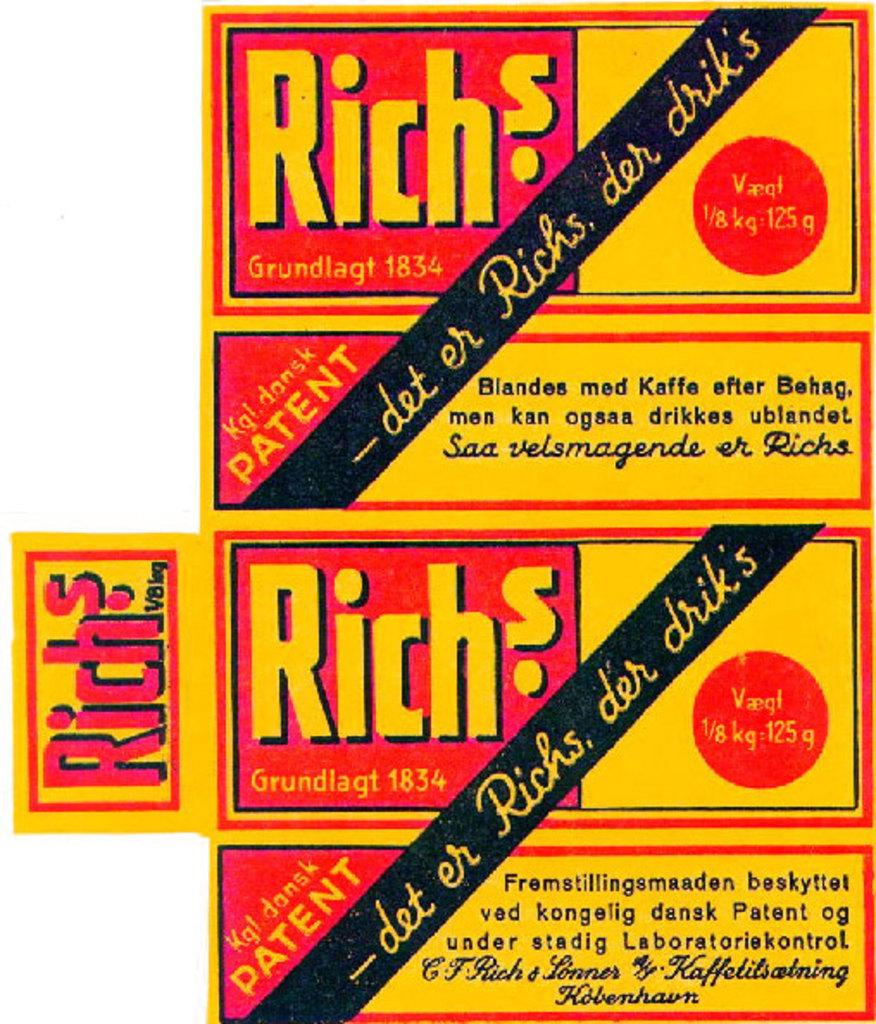<image>
Provide a brief description of the given image. A red and yellow advertisement with the word Richs on it. 